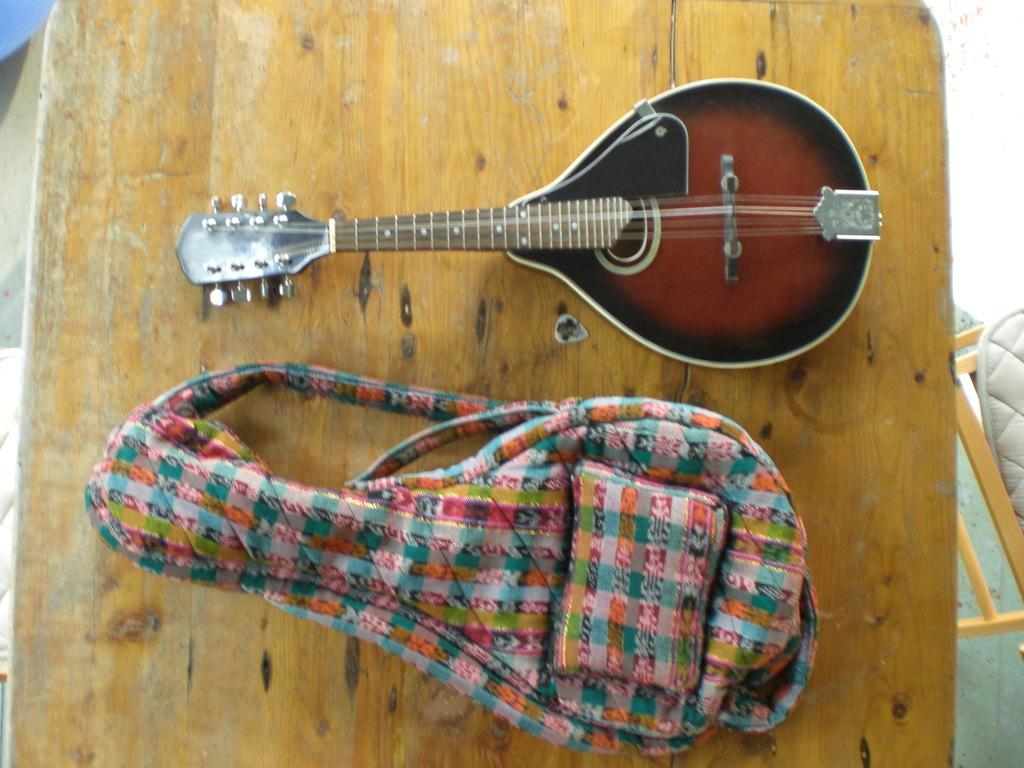What musical instrument is on the table in the image? There is a beautiful guitar on a table in the image. What is located beside the table? There is a guitar bag beside the table. What can be said about the appearance of the guitar bag? The guitar bag is colorful. What piece of furniture is on the right side of the table? There is a chair on the right side of the table. What emotion is displayed on the face of the guitar in the image? There is no face on the guitar, so it cannot display any emotion. 